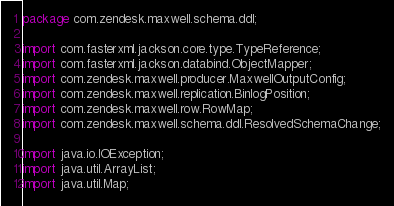Convert code to text. <code><loc_0><loc_0><loc_500><loc_500><_Java_>package com.zendesk.maxwell.schema.ddl;

import com.fasterxml.jackson.core.type.TypeReference;
import com.fasterxml.jackson.databind.ObjectMapper;
import com.zendesk.maxwell.producer.MaxwellOutputConfig;
import com.zendesk.maxwell.replication.BinlogPosition;
import com.zendesk.maxwell.row.RowMap;
import com.zendesk.maxwell.schema.ddl.ResolvedSchemaChange;

import java.io.IOException;
import java.util.ArrayList;
import java.util.Map;</code> 